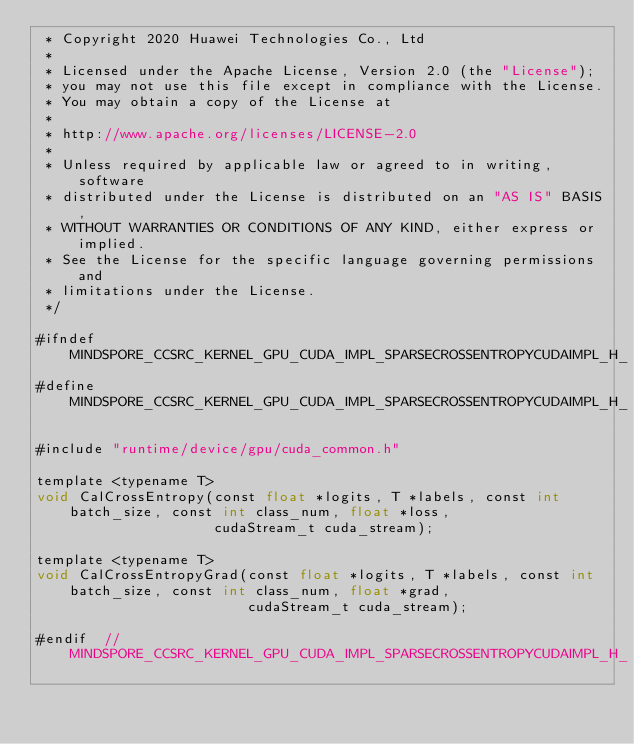<code> <loc_0><loc_0><loc_500><loc_500><_Cuda_> * Copyright 2020 Huawei Technologies Co., Ltd
 *
 * Licensed under the Apache License, Version 2.0 (the "License");
 * you may not use this file except in compliance with the License.
 * You may obtain a copy of the License at
 *
 * http://www.apache.org/licenses/LICENSE-2.0
 *
 * Unless required by applicable law or agreed to in writing, software
 * distributed under the License is distributed on an "AS IS" BASIS,
 * WITHOUT WARRANTIES OR CONDITIONS OF ANY KIND, either express or implied.
 * See the License for the specific language governing permissions and
 * limitations under the License.
 */

#ifndef MINDSPORE_CCSRC_KERNEL_GPU_CUDA_IMPL_SPARSECROSSENTROPYCUDAIMPL_H_
#define MINDSPORE_CCSRC_KERNEL_GPU_CUDA_IMPL_SPARSECROSSENTROPYCUDAIMPL_H_

#include "runtime/device/gpu/cuda_common.h"

template <typename T>
void CalCrossEntropy(const float *logits, T *labels, const int batch_size, const int class_num, float *loss,
                     cudaStream_t cuda_stream);

template <typename T>
void CalCrossEntropyGrad(const float *logits, T *labels, const int batch_size, const int class_num, float *grad,
                         cudaStream_t cuda_stream);

#endif  // MINDSPORE_CCSRC_KERNEL_GPU_CUDA_IMPL_SPARSECROSSENTROPYCUDAIMPL_H_
</code> 